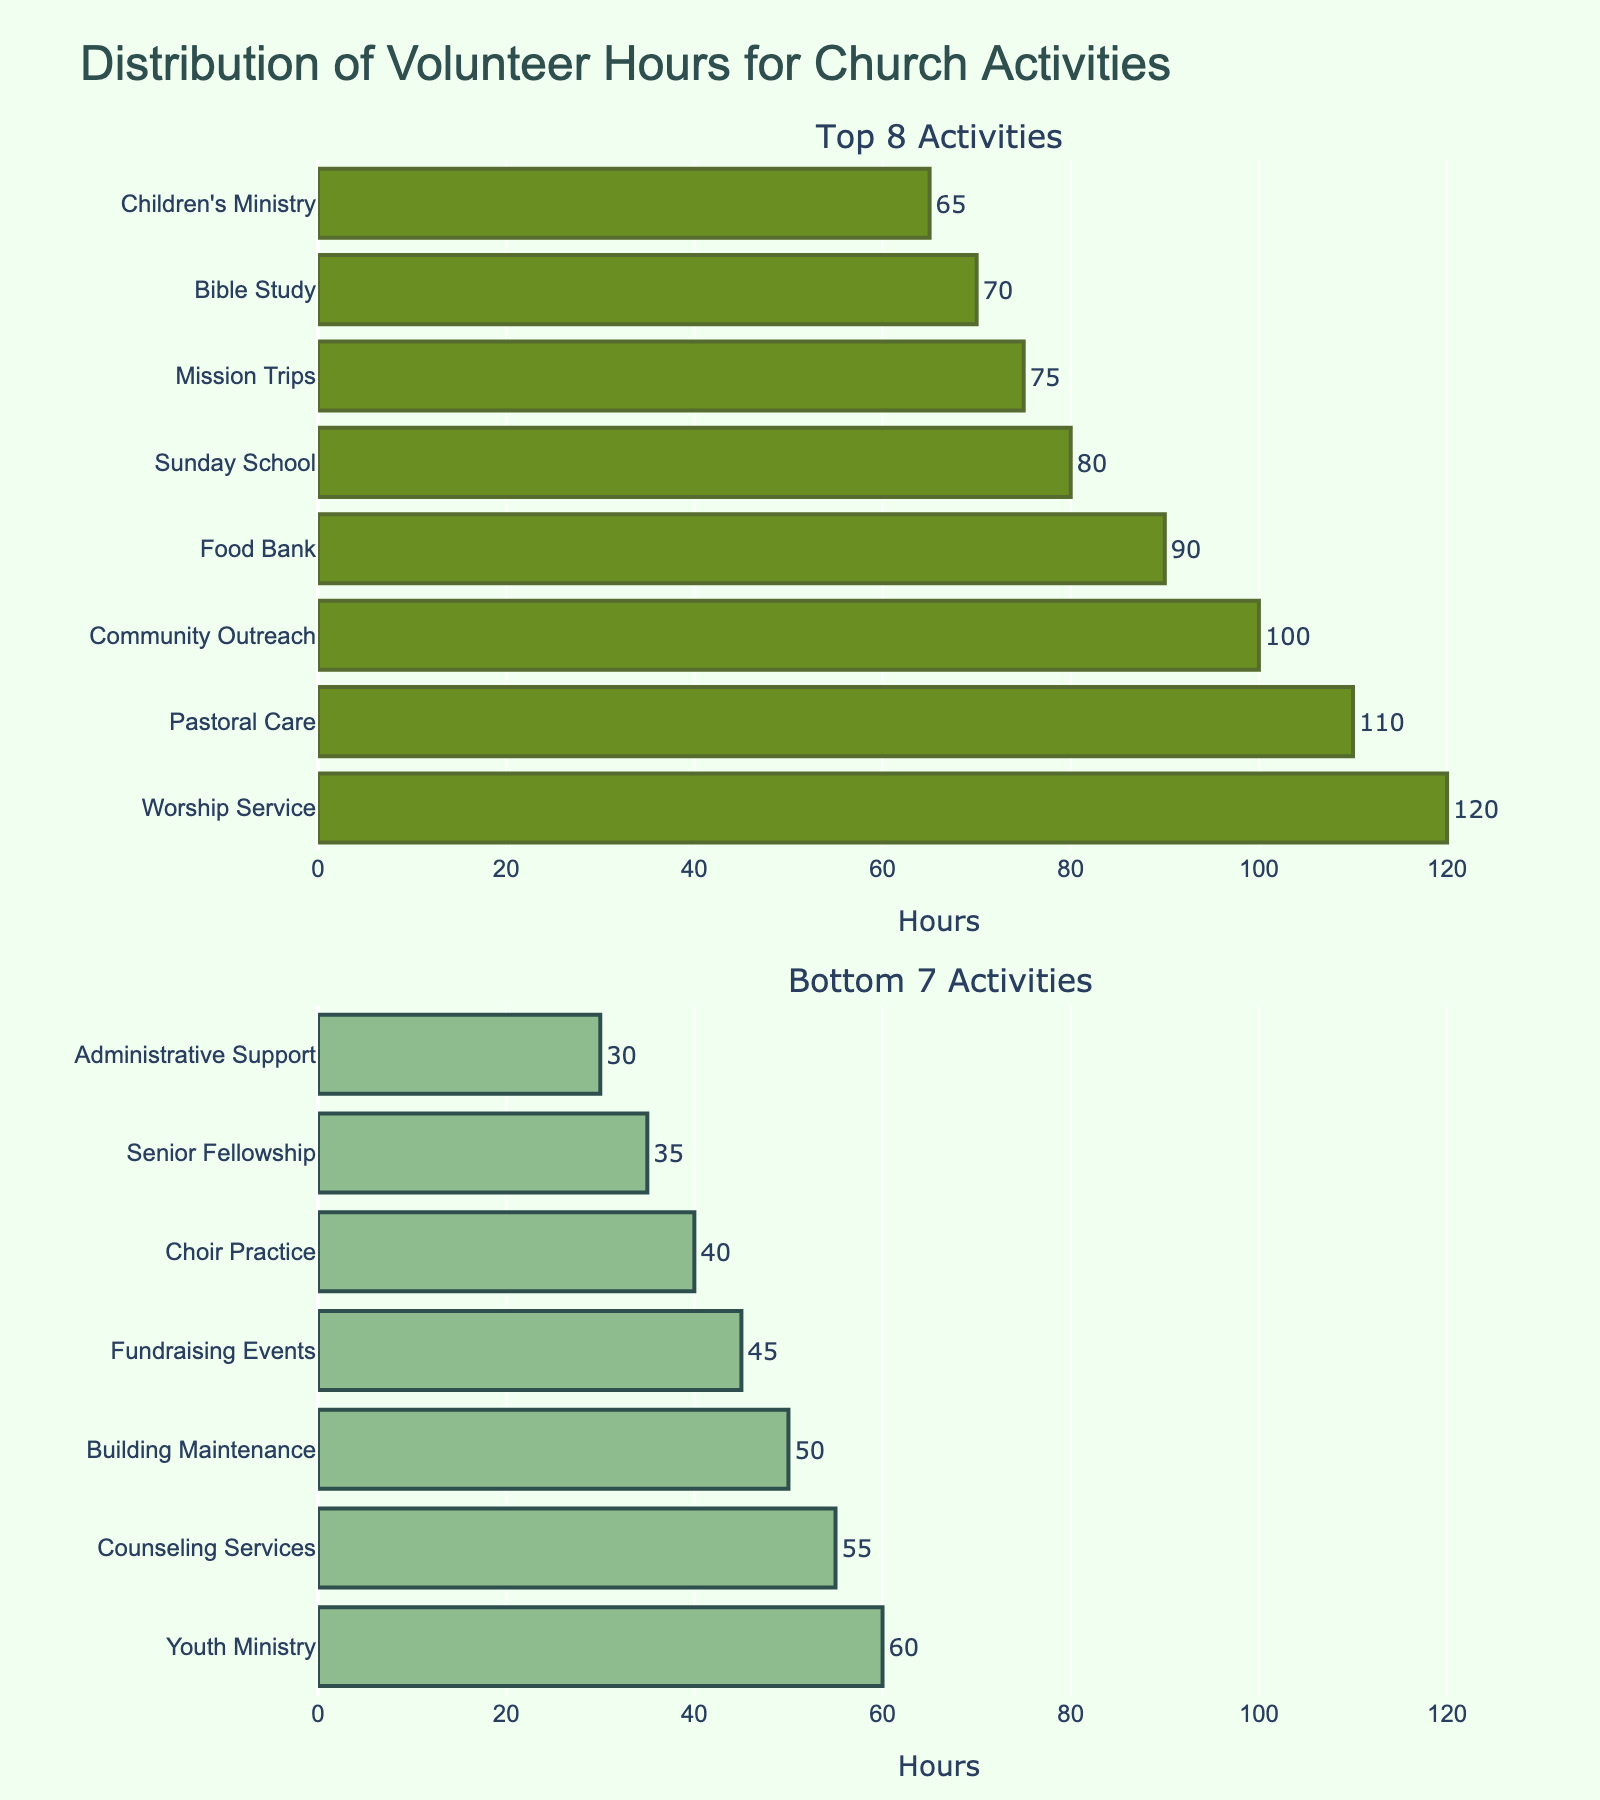What is the title of the figure? The title of the figure helps to understand the central theme of the visual representation. Looking at the top part, the title "Impact of Media Exposure on Self-Esteem Across Cultures" is easily noticeable.
Answer: Impact of Media Exposure on Self-Esteem Across Cultures Which culture shows the highest self-esteem score for social media exposure? To determine this, check the bar heights for social media exposure across all subplots. In the Brazil subplot, the social media bar is the tallest, indicating the highest score.
Answer: Brazil Which media type has the lowest self-esteem score in Japan? To find the lowest self-esteem score in Japan, observe the subplot for Japan. The lowest bar represents social media.
Answer: Social Media What is the difference in self-esteem scores between social media exposure in the USA and Germany? Find the bars for social media exposure in the USA and Germany subplots. The USA bar is at 6.2, and the Germany bar is at 6.4. Calculate 6.4 - 6.2 to get the difference.
Answer: 0.2 What is the average self-esteem score across all media types in India? Sum the self-esteem scores for all media types in the India subplot: 6.7 (Social Media) + 7.3 (Television) + 7.0 (Print Media) + 6.5 (Video Games) = 27.5. Then, divide by 4 (number of media types): 27.5 / 4.
Answer: 6.9 Which media type has the most similar self-esteem scores across all cultures? Compare the bar heights for each media type across all subplots. Television has relatively consistent heights in all subplots, indicating similar self-esteem scores.
Answer: Television In which culture is the difference between the highest and the lowest self-esteem scores the greatest? Calculate the range (difference between the highest and lowest scores) for each culture. Brazil has the greatest range: 7.4 (Television) - 6.8 (Print Media) = 0.6.
Answer: Brazil Rank the cultures in order of print media's impact on self-esteem from highest to lowest. Observe the heights of the print media bars in each subplot. Rank from highest to lowest: USA (7.5), Germany (7.3), Japan (7.2), India (7.0), Brazil (6.8).
Answer: USA, Germany, Japan, India, Brazil 